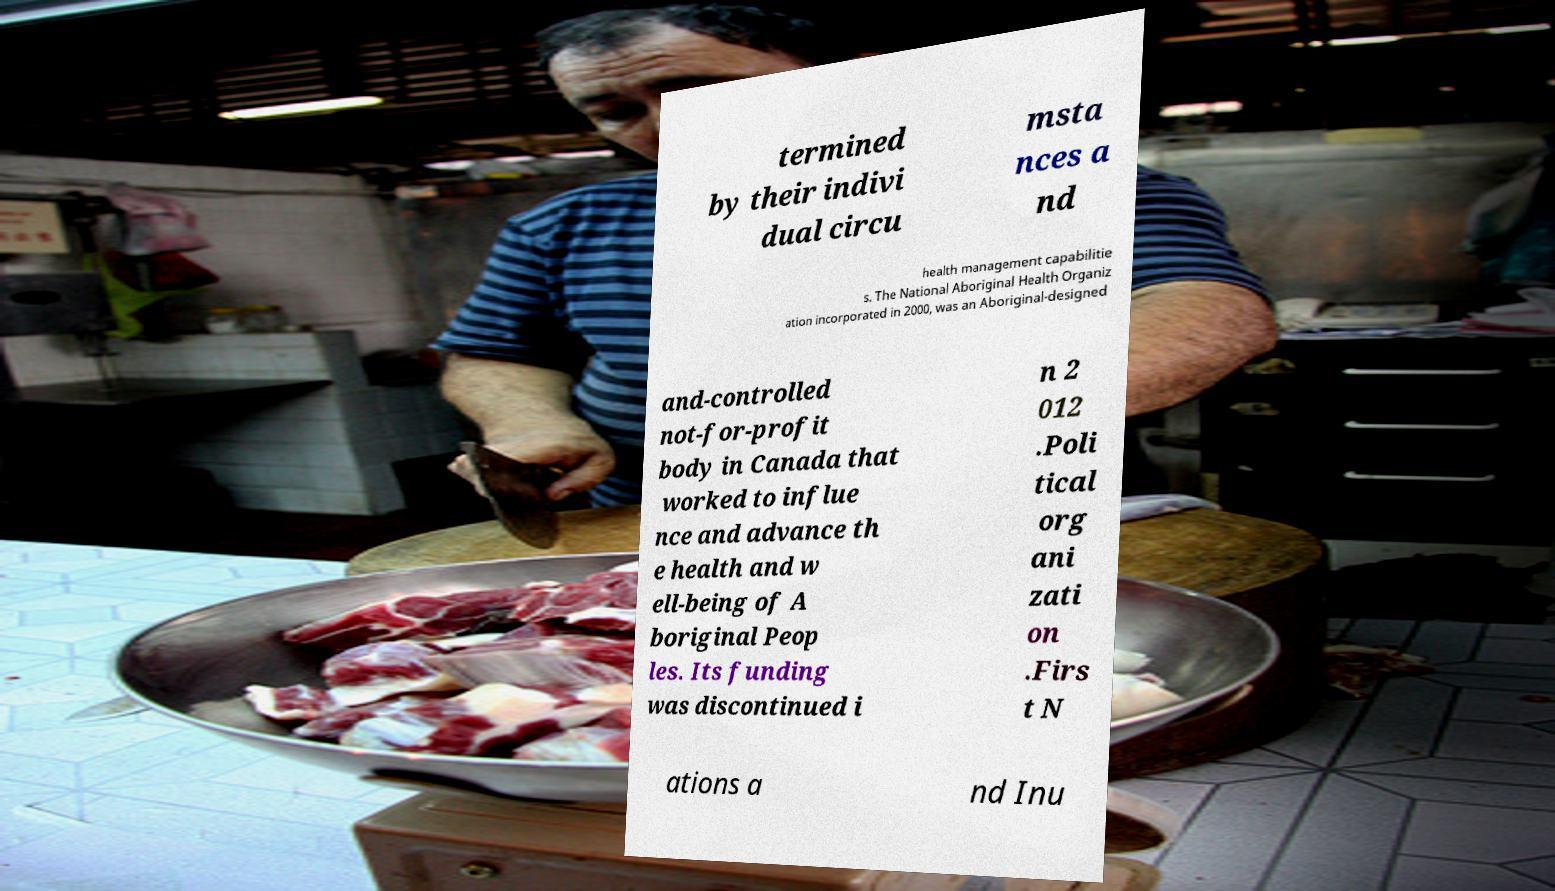What messages or text are displayed in this image? I need them in a readable, typed format. termined by their indivi dual circu msta nces a nd health management capabilitie s. The National Aboriginal Health Organiz ation incorporated in 2000, was an Aboriginal-designed and-controlled not-for-profit body in Canada that worked to influe nce and advance th e health and w ell-being of A boriginal Peop les. Its funding was discontinued i n 2 012 .Poli tical org ani zati on .Firs t N ations a nd Inu 